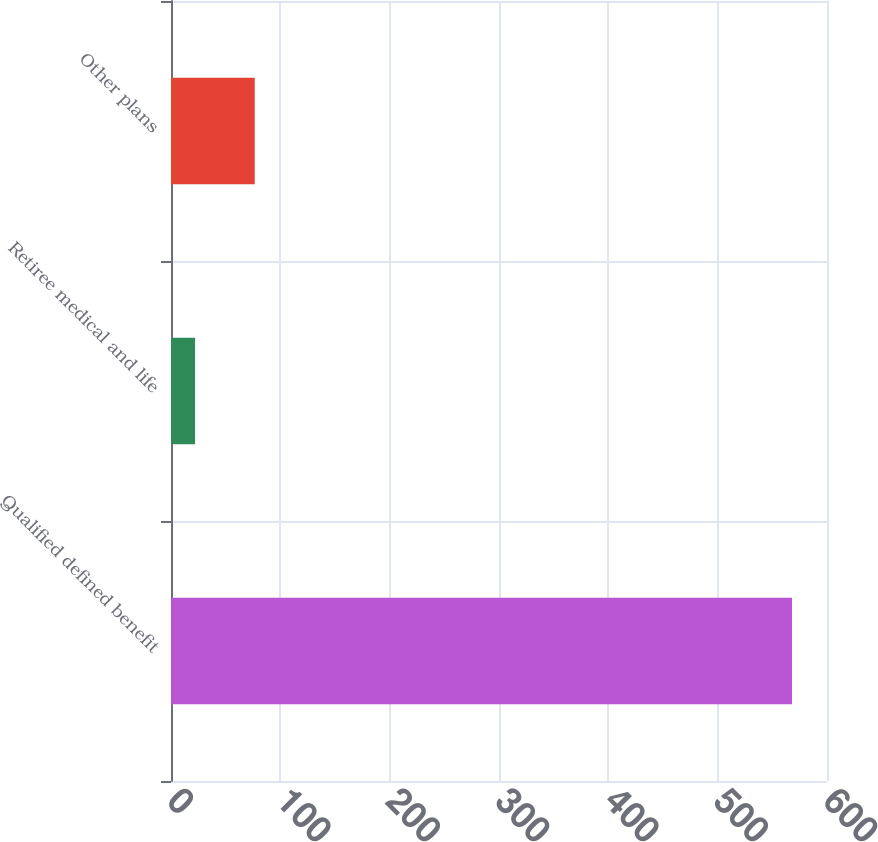Convert chart to OTSL. <chart><loc_0><loc_0><loc_500><loc_500><bar_chart><fcel>Qualified defined benefit<fcel>Retiree medical and life<fcel>Other plans<nl><fcel>568<fcel>22<fcel>76.6<nl></chart> 